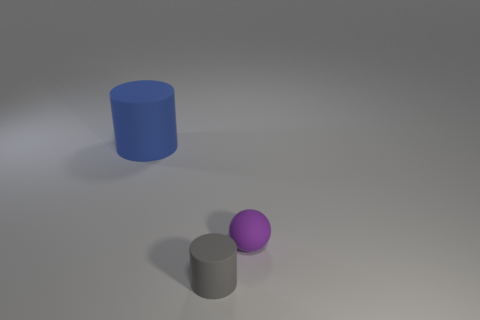Is there anything else that is the same size as the blue cylinder?
Provide a short and direct response. No. What is the size of the gray rubber thing?
Keep it short and to the point. Small. There is a rubber cylinder in front of the cylinder that is on the left side of the cylinder in front of the blue rubber cylinder; how big is it?
Your answer should be very brief. Small. Is there a blue cylinder that has the same material as the big thing?
Provide a succinct answer. No. There is a tiny purple matte object; what shape is it?
Provide a succinct answer. Sphere. What is the color of the tiny cylinder that is made of the same material as the purple object?
Offer a terse response. Gray. What number of blue objects are big matte things or rubber spheres?
Ensure brevity in your answer.  1. Are there more tiny gray cylinders than rubber objects?
Make the answer very short. No. How many things are either cylinders that are in front of the small purple object or matte cylinders in front of the big rubber cylinder?
Offer a very short reply. 1. There is a matte ball that is the same size as the gray matte cylinder; what is its color?
Give a very brief answer. Purple. 